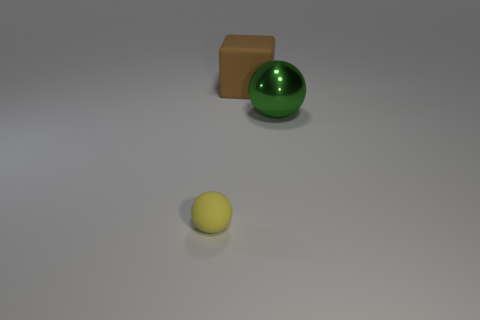Is there any other thing that has the same shape as the brown matte thing?
Keep it short and to the point. No. Does the big brown cube have the same material as the ball that is in front of the metallic sphere?
Keep it short and to the point. Yes. There is a object that is on the right side of the large cube; what color is it?
Offer a terse response. Green. Is there a metal thing that is behind the matte thing that is in front of the green shiny thing?
Provide a short and direct response. Yes. Is the color of the object on the right side of the large block the same as the matte object on the right side of the yellow rubber thing?
Your answer should be very brief. No. There is a big cube; what number of small yellow rubber balls are to the left of it?
Your answer should be very brief. 1. How many metallic objects have the same color as the small matte object?
Ensure brevity in your answer.  0. Is the material of the sphere on the right side of the yellow sphere the same as the cube?
Your answer should be compact. No. How many other big cubes have the same material as the big block?
Give a very brief answer. 0. Is the number of green metal spheres that are behind the small ball greater than the number of yellow cylinders?
Your answer should be very brief. Yes. 